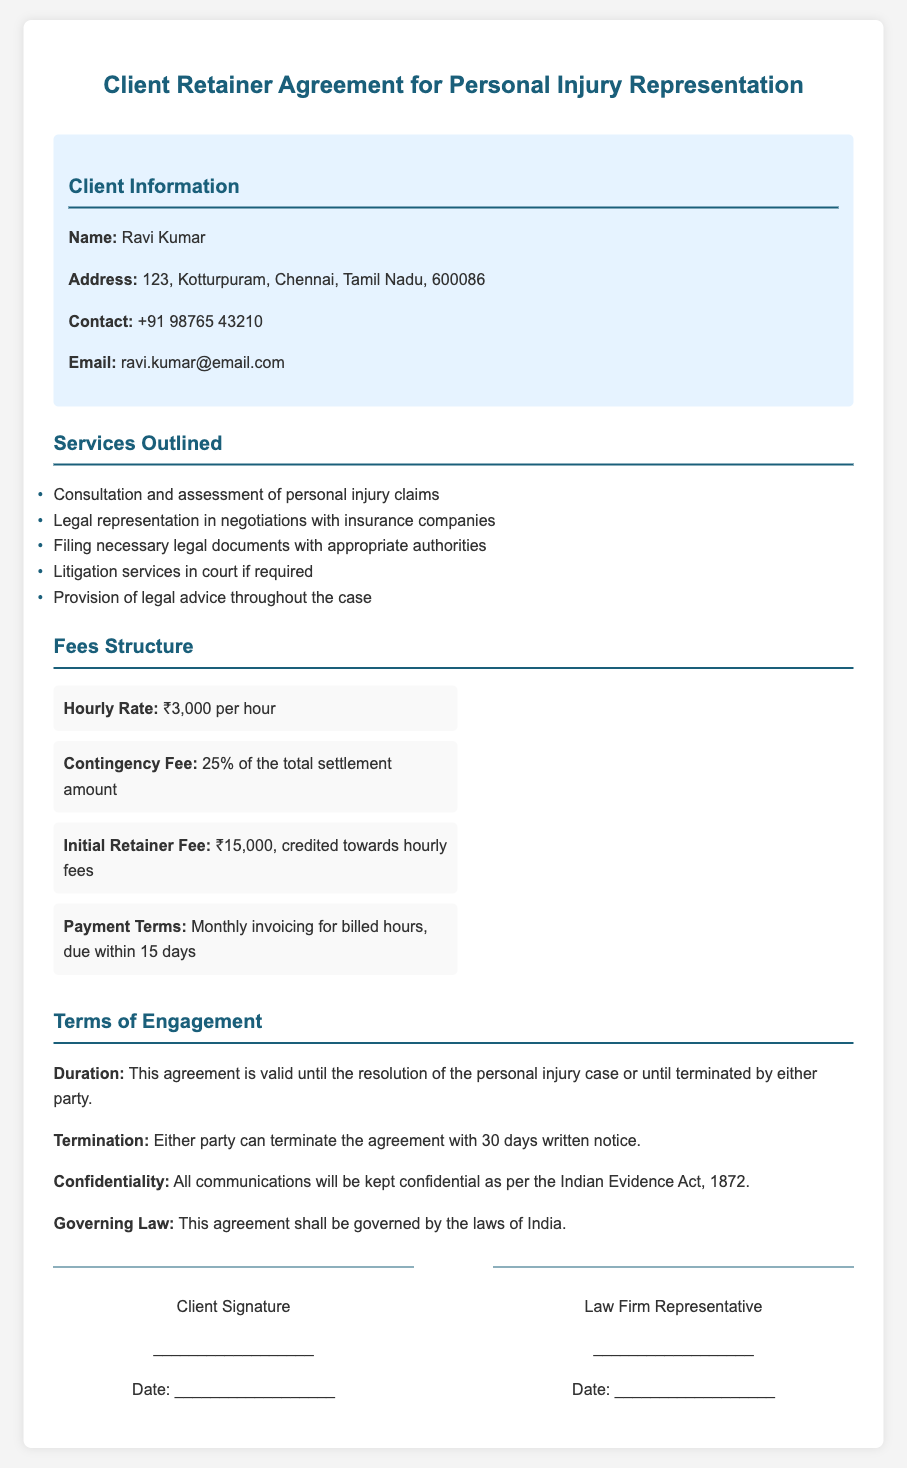What is the client's name? The client's name is explicitly mentioned in the document under the client information section.
Answer: Ravi Kumar What is the hourly rate charged by the law firm? The hourly rate is specified in the fees structure section of the document.
Answer: ₹3,000 per hour What is the initial retainer fee amount? The initial retainer fee is detailed in the fees structure part of the document.
Answer: ₹15,000 What percentage of the total settlement amount serves as the contingency fee? The contingency fee percentage is outlined in the fees section of the document.
Answer: 25% What duration is the agreement valid for? The validity duration of the agreement is stated in the terms of engagement section.
Answer: Until the resolution of the personal injury case How many days written notice is required for termination? The document specifies the notice period for termination in the terms of engagement.
Answer: 30 days What law governs this agreement? The governing law for the agreement is mentioned in the terms of engagement section.
Answer: Laws of India What is the payment terms for the invoiced hours? The payment terms are specified in the fees structure section of the document.
Answer: Monthly invoicing for billed hours, due within 15 days What type of law does this agreement relate to? The document clearly states the type of legal representation in the title and content.
Answer: Personal injury cases 